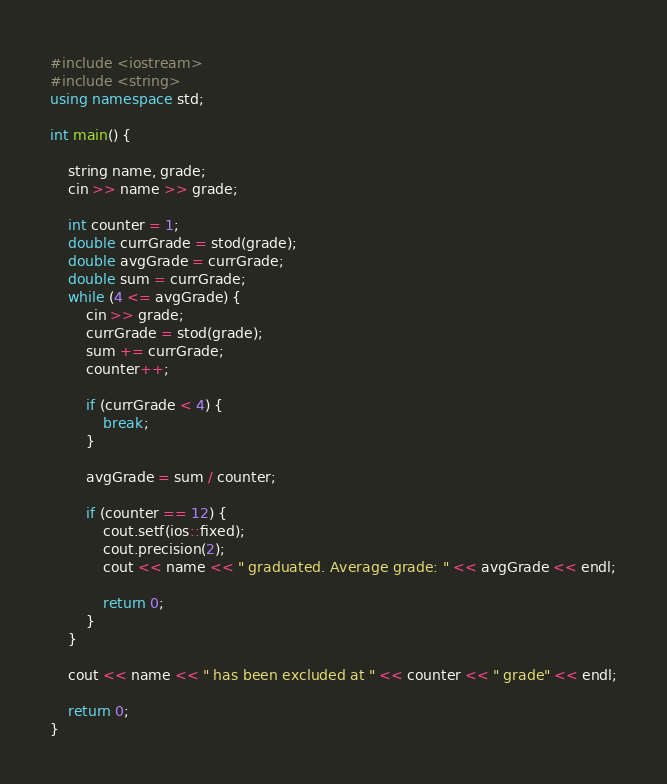Convert code to text. <code><loc_0><loc_0><loc_500><loc_500><_C++_>#include <iostream>
#include <string>
using namespace std;

int main() {

	string name, grade;
	cin >> name >> grade;

	int counter = 1;
	double currGrade = stod(grade);
	double avgGrade = currGrade;
	double sum = currGrade;
	while (4 <= avgGrade) {
		cin >> grade;
		currGrade = stod(grade);
		sum += currGrade;
		counter++;

		if (currGrade < 4) {
			break;
		}

		avgGrade = sum / counter;

		if (counter == 12) {
			cout.setf(ios::fixed);
			cout.precision(2);
			cout << name << " graduated. Average grade: " << avgGrade << endl;

			return 0;
		}
	}

	cout << name << " has been excluded at " << counter << " grade" << endl;

	return 0;
}
</code> 